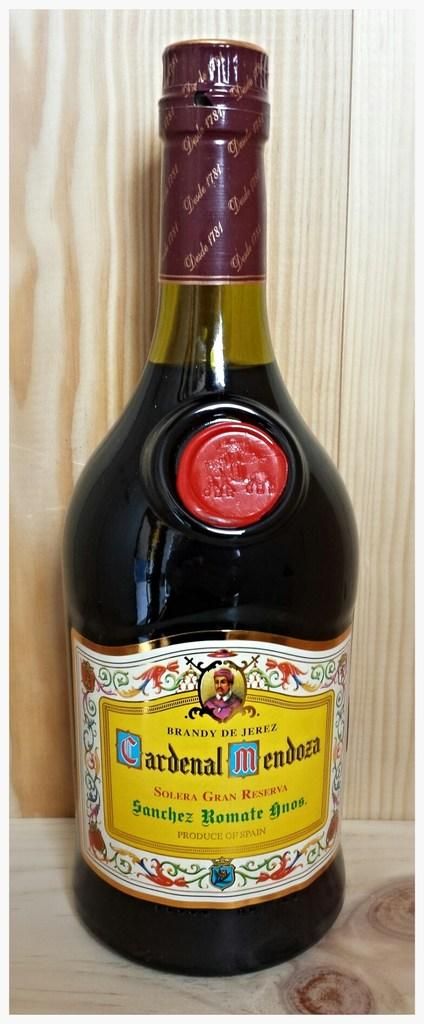<image>
Create a compact narrative representing the image presented. Black bottle with a yellow label which says "Cardenal Mendoza" on it. 